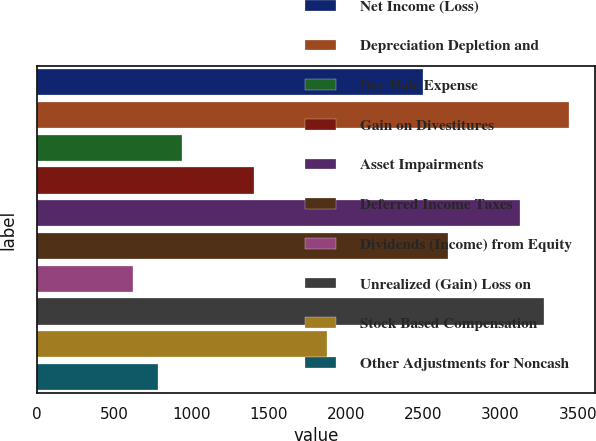Convert chart. <chart><loc_0><loc_0><loc_500><loc_500><bar_chart><fcel>Net Income (Loss)<fcel>Depreciation Depletion and<fcel>Dry Hole Expense<fcel>Gain on Divestitures<fcel>Asset Impairments<fcel>Deferred Income Taxes<fcel>Dividends (Income) from Equity<fcel>Unrealized (Gain) Loss on<fcel>Stock Based Compensation<fcel>Other Adjustments for Noncash<nl><fcel>2501.8<fcel>3439.6<fcel>938.8<fcel>1407.7<fcel>3127<fcel>2658.1<fcel>626.2<fcel>3283.3<fcel>1876.6<fcel>782.5<nl></chart> 